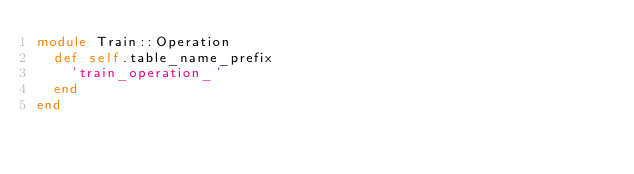<code> <loc_0><loc_0><loc_500><loc_500><_Ruby_>module Train::Operation
  def self.table_name_prefix
    'train_operation_'
  end
end
</code> 